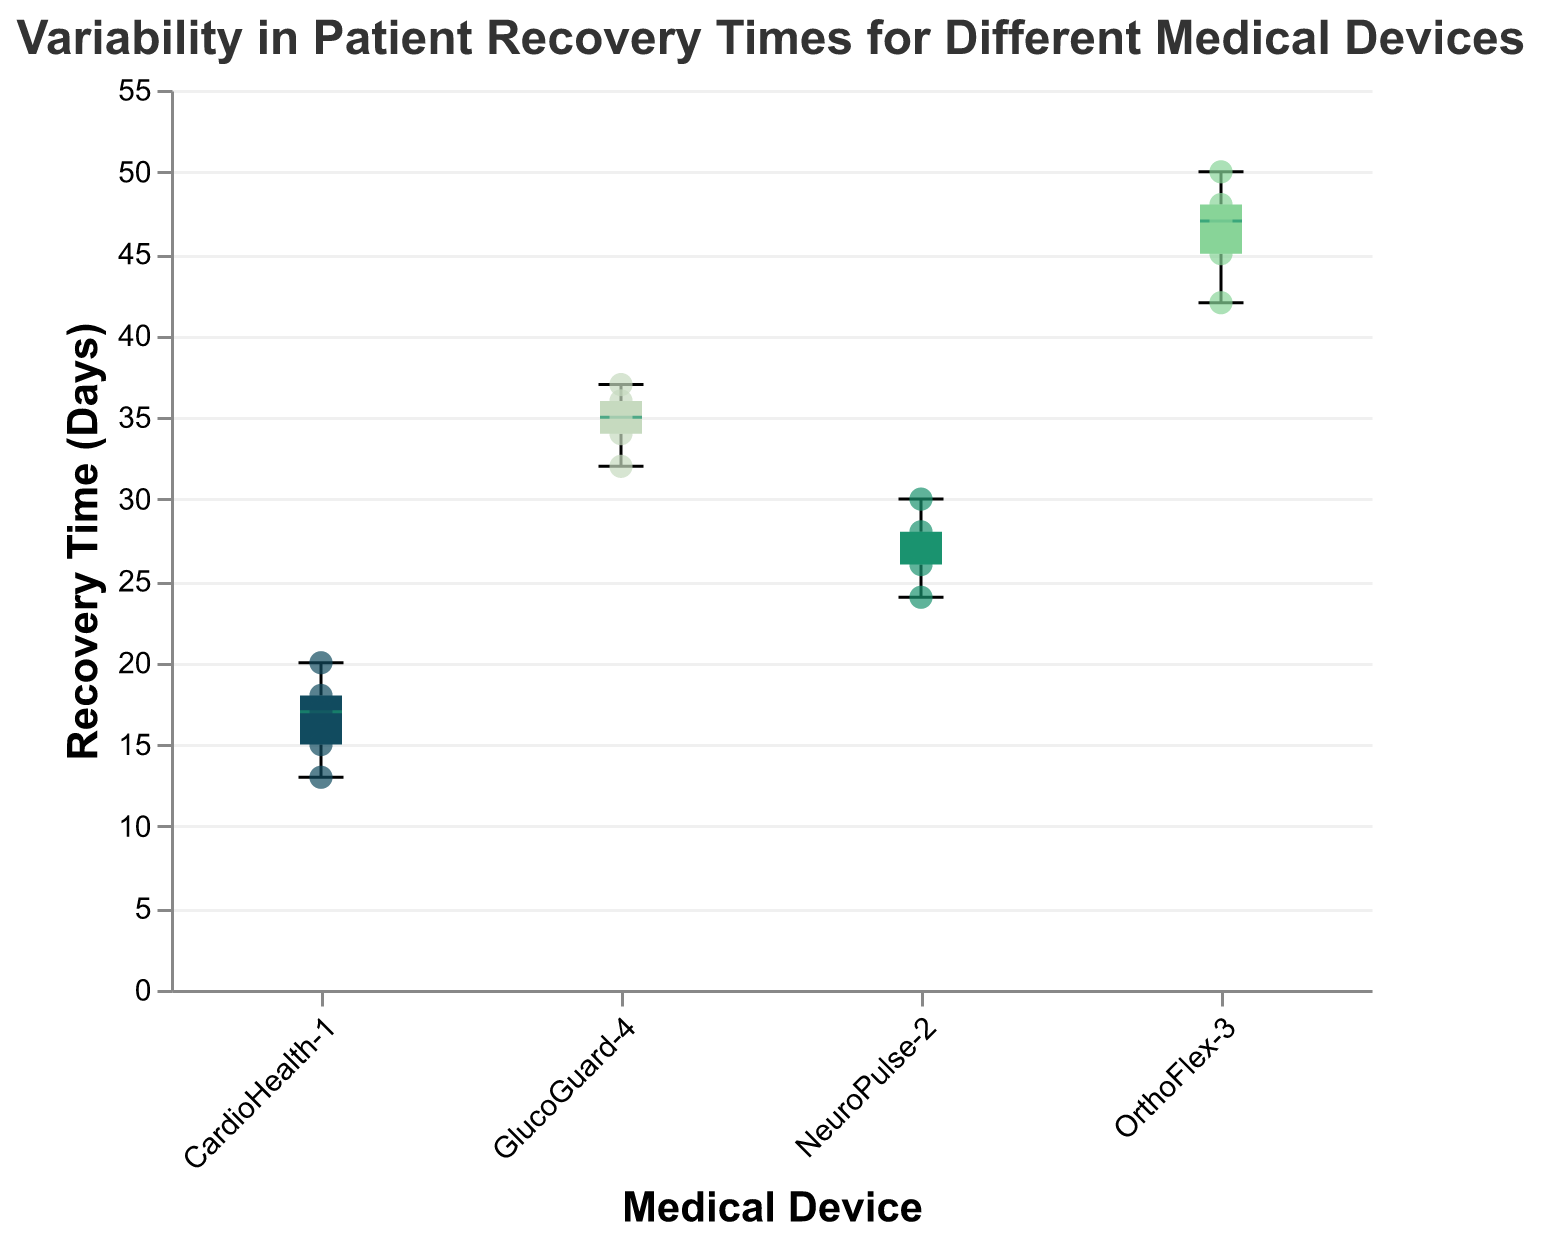What is the median recovery time for CardioHealth-1? The median recovery time for CardioHealth-1 is the middle value when the recovery times are listed in order. The values are 13, 15, 17, 18, and 20. The median is 17.
Answer: 17 Which medical device has the highest maximum recovery time? The maximum recovery time for each device can be seen at the top whisker of the box plot. OrthoFlex-3 has the highest maximum recovery time of 50 days.
Answer: OrthoFlex-3 What is the range of recovery times for NeuroPulse-2? The range is calculated by subtracting the minimum value from the maximum value for NeuroPulse-2. The maximum value is 30, and the minimum value is 24. Therefore, the range is 30 - 24 = 6 days.
Answer: 6 How many devices have a median recovery time above 20 days? By looking at the median line in each box plot, we can see that OrthoFlex-3 and GlucoGuard-4 have median recovery times above 20 days. Thus, there are 2 devices.
Answer: 2 Which device has the smallest interquartile range (IQR) of recovery times? The IQR is the difference between the third and first quartile (Q3 - Q1). Observing the length of the boxes, NeuroPulse-2 has the smallest IQR.
Answer: NeuroPulse-2 What is the interquartile range (IQR) for GlucoGuard-4? The IQR is the difference between the upper quartile (Q3) and the lower quartile (Q1) for GlucoGuard-4. From the figure, Q3 is approximately 36.5, and Q1 is approximately 33, so IQR = 36.5 - 33 = 3.5 days.
Answer: 3.5 Is there an outlier in the recovery times for OrthoFlex-3? Checking for any data points beyond the whiskers of the OrthoFlex-3 box plot, we find no points that can be considered as outliers.
Answer: No Which device shows the greatest variability in patient recovery times? The device with the greatest variability can be identified by the length of its whiskers. OrthoFlex-3 has the longest whiskers indicating the greatest variability.
Answer: OrthoFlex-3 What's the median recovery time difference between GlucoGuard-4 and NeuroPulse-2? To find the median difference between GlucoGuard-4 and NeuroPulse-2, subtract NeuroPulse-2's median from GlucoGuard-4's median. From the figure, GlucoGuard-4’s median is about 35, and NeuroPulse-2’s is about 27, so the difference is 35 - 27 = 8 days.
Answer: 8 What is the color used to represent CardioHealth-1 in the plot? Each device is represented by a different color in the plot. CardioHealth-1 is represented by navy blue.
Answer: Navy blue 